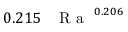<formula> <loc_0><loc_0><loc_500><loc_500>0 . 2 1 5 \, { R a } ^ { 0 . 2 0 6 }</formula> 